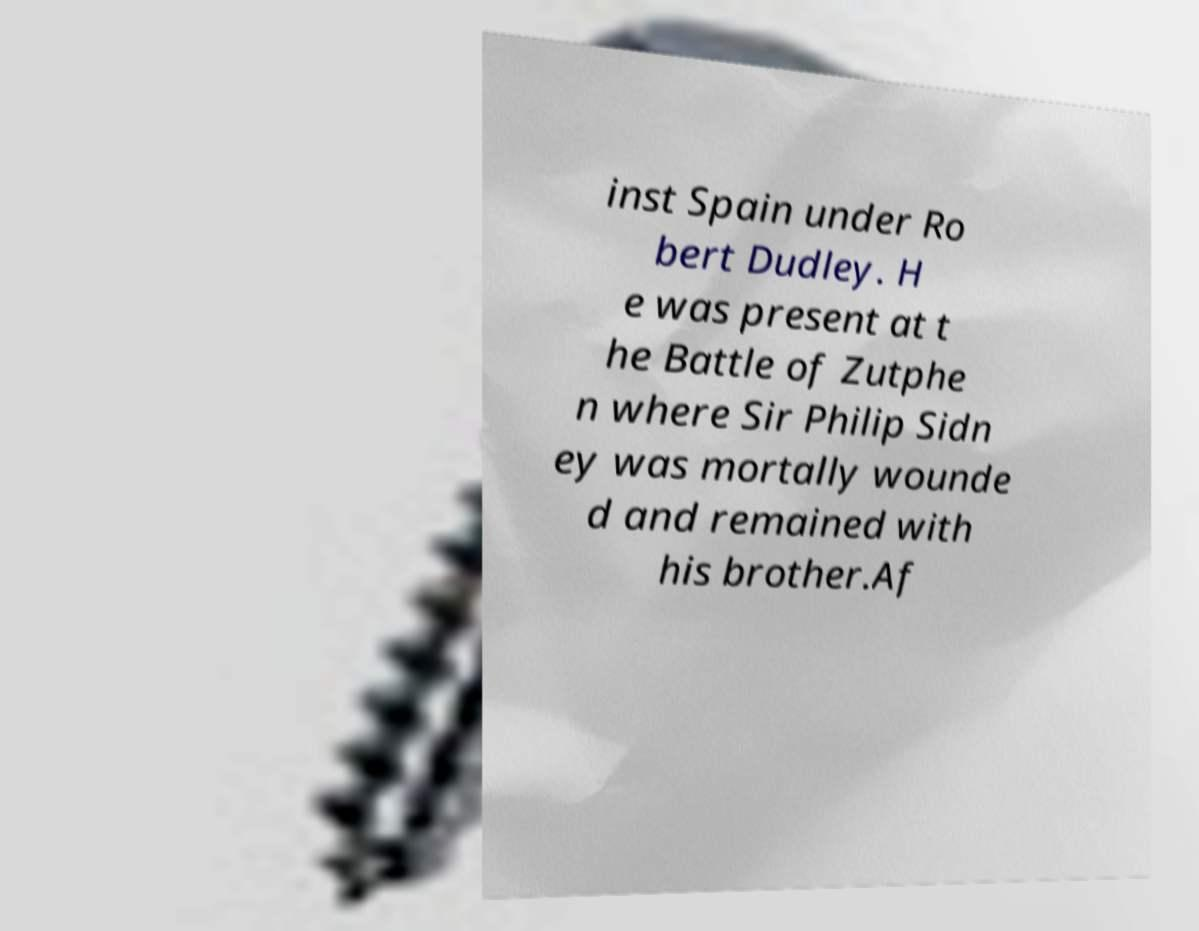There's text embedded in this image that I need extracted. Can you transcribe it verbatim? inst Spain under Ro bert Dudley. H e was present at t he Battle of Zutphe n where Sir Philip Sidn ey was mortally wounde d and remained with his brother.Af 